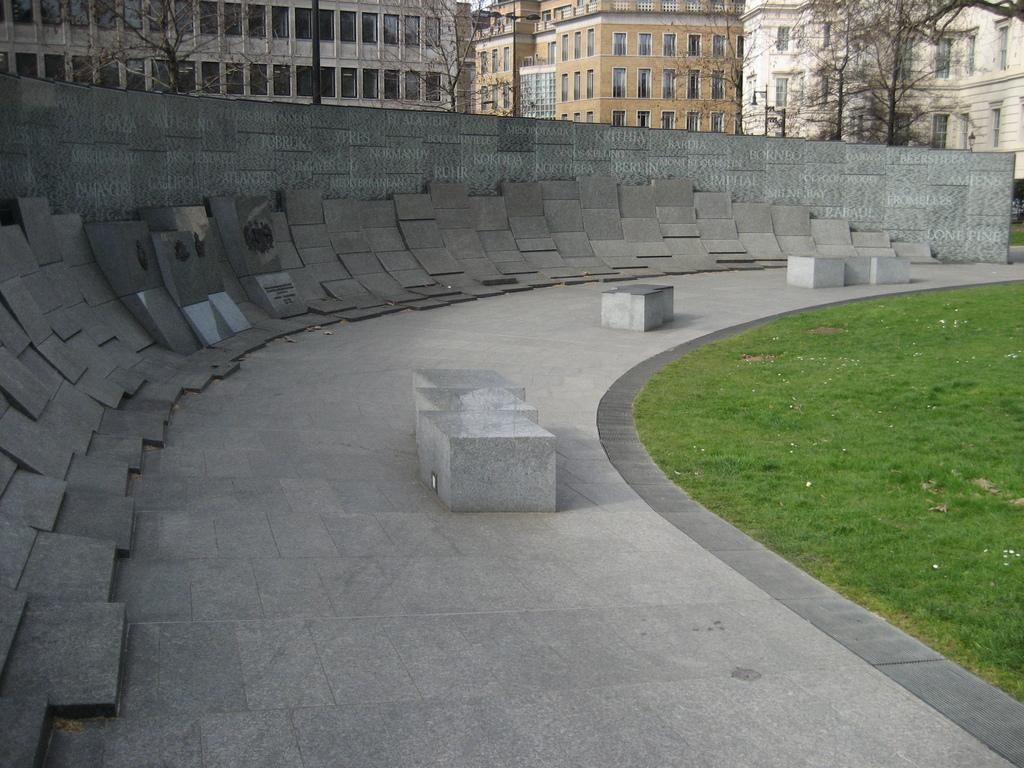What is located at the bottom of the image? There is a walkway at the bottom of the image. What can be found near the walkway? There are boards near the walkway. What type of vegetation is on the right side of the image? There is grass on the right side of the image. What can be seen in the background of the image? There are buildings, trees, and poles in the background of the image. What does the caption say about the father in the image? There is no caption or father present in the image. What type of medical facility is shown in the image? There is no hospital or medical facility shown in the image. 